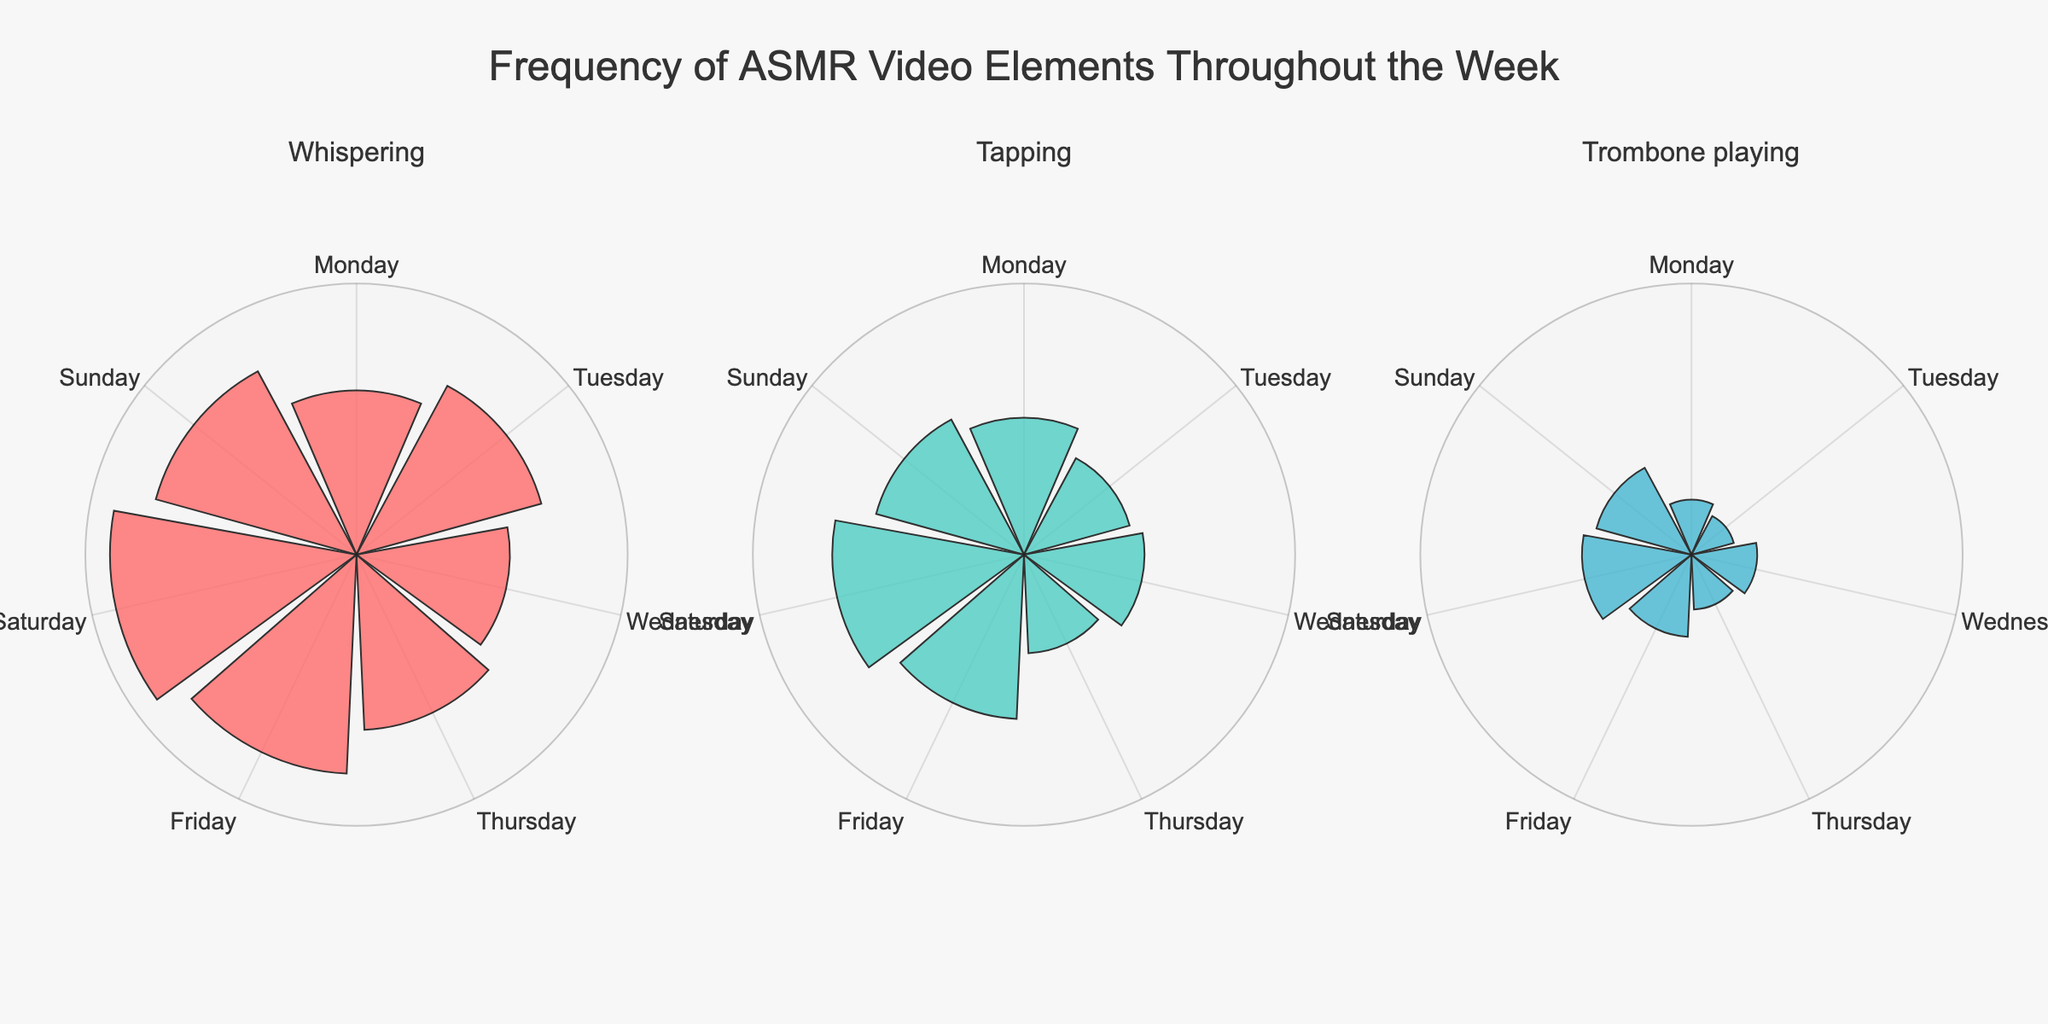What's the title of this figure? The title of the figure is displayed at the top and generally provides a summary of what the figure is about. By looking at the top of the figure, we can see the title.
Answer: Frequency of ASMR Video Elements Throughout the Week Which day has the highest frequency of whispering? To find the day with the highest frequency of whispering, we need to look at the subplot for whispering and identify which day has the longest bar. By examining the plot, Saturday has the highest frequency.
Answer: Saturday How does the frequency of tapping on Friday compare to Thursday? To compare the frequencies, we look at the subplot for tapping and find the bars for Thursday and Friday. The bar for Friday is longer than that for Thursday, indicating a higher frequency.
Answer: Friday is higher What is the average frequency of trombone playing throughout the week? To find the average, we sum the frequencies for each day and divide by the number of days. The frequencies are: 10 + 8 + 12 + 10 + 15 + 20 + 18 = 93. The average is 93/7.
Answer: 13.29 Which ASMR element has the lowest frequency on Wednesday? By inspecting the three subplots for Wednesday, we compare the lengths of the bars for whispering, tapping, and trombone playing. Trombone playing has the shortest bar on Wednesday.
Answer: Trombone playing Are there any elements with a consistent increase or decrease throughout the week? We inspect the subplots for each element and observe how the bar lengths change from Monday to Sunday. Whispering consistently increases from Monday to Saturday before decreasing slightly on Sunday.
Answer: Whispering increases What's the total frequency of all elements on Monday? To find the total frequency for Monday, sum the frequencies of whispering, tapping, and trombone playing. The frequencies are 30 (whispering) + 25 (tapping) + 10 (trombone playing).
Answer: 65 Which day has the highest total frequency across all elements? To determine this, we sum the frequencies of all three elements for each day and compare. By calculation: 
- Monday: 65 
- Tuesday: 63 
- Wednesday: 62 
- Thursday: 60 
- Friday: 85 
- Saturday: 100 
- Sunday: 84 
Saturday has the highest total.
Answer: Saturday Which day shows the highest frequency for all three elements in their respective subplots? By examining each subplot individually, we find the longest bars for whispering, tapping, and trombone playing. All bars are longest on Saturday for each respective element.
Answer: Saturday 